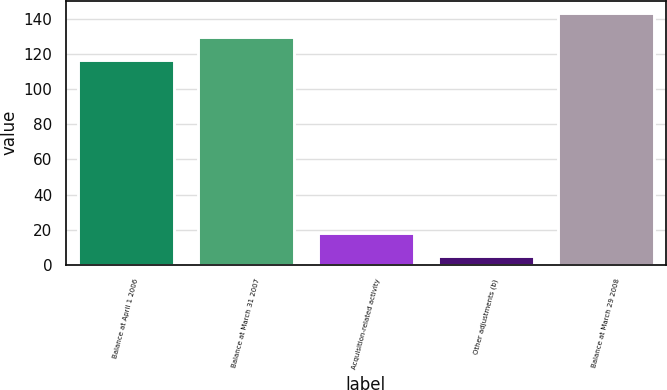<chart> <loc_0><loc_0><loc_500><loc_500><bar_chart><fcel>Balance at April 1 2006<fcel>Balance at March 31 2007<fcel>Acquisition-related activity<fcel>Other adjustments (b)<fcel>Balance at March 29 2008<nl><fcel>116.5<fcel>129.83<fcel>18.23<fcel>4.9<fcel>143.16<nl></chart> 